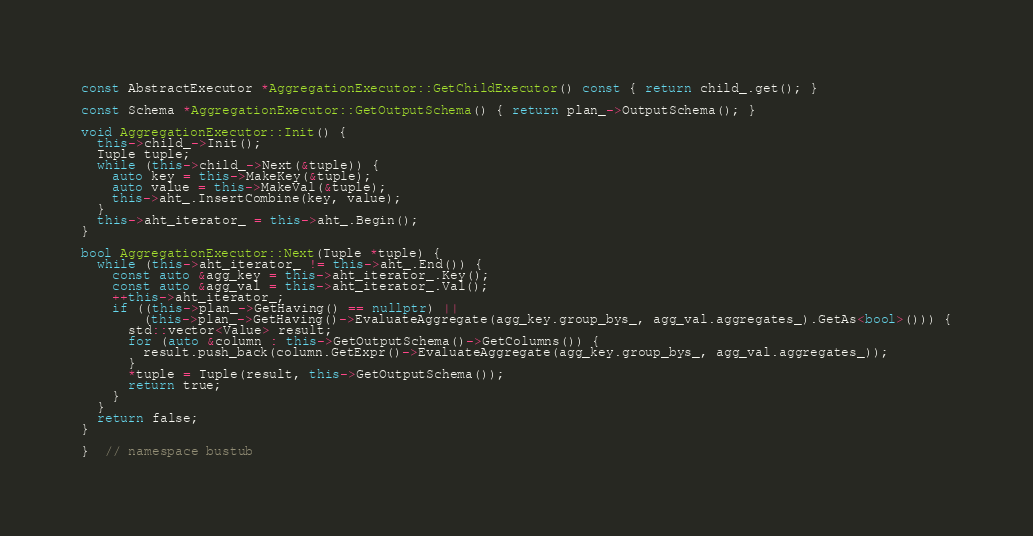Convert code to text. <code><loc_0><loc_0><loc_500><loc_500><_C++_>
const AbstractExecutor *AggregationExecutor::GetChildExecutor() const { return child_.get(); }

const Schema *AggregationExecutor::GetOutputSchema() { return plan_->OutputSchema(); }

void AggregationExecutor::Init() {
  this->child_->Init();
  Tuple tuple;
  while (this->child_->Next(&tuple)) {
    auto key = this->MakeKey(&tuple);
    auto value = this->MakeVal(&tuple);
    this->aht_.InsertCombine(key, value);
  }
  this->aht_iterator_ = this->aht_.Begin();
}

bool AggregationExecutor::Next(Tuple *tuple) {
  while (this->aht_iterator_ != this->aht_.End()) {
    const auto &agg_key = this->aht_iterator_.Key();
    const auto &agg_val = this->aht_iterator_.Val();
    ++this->aht_iterator_;
    if ((this->plan_->GetHaving() == nullptr) ||
        (this->plan_->GetHaving()->EvaluateAggregate(agg_key.group_bys_, agg_val.aggregates_).GetAs<bool>())) {
      std::vector<Value> result;
      for (auto &column : this->GetOutputSchema()->GetColumns()) {
        result.push_back(column.GetExpr()->EvaluateAggregate(agg_key.group_bys_, agg_val.aggregates_));
      }
      *tuple = Tuple(result, this->GetOutputSchema());
      return true;
    }
  }
  return false;
}

}  // namespace bustub
</code> 